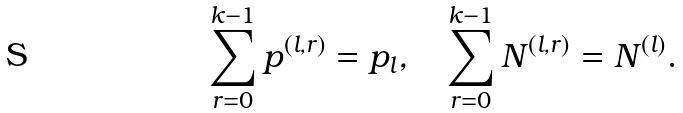Convert formula to latex. <formula><loc_0><loc_0><loc_500><loc_500>\sum _ { r = 0 } ^ { k - 1 } p ^ { ( l , r ) } = p _ { l } , \quad \sum _ { r = 0 } ^ { k - 1 } N ^ { ( l , r ) } = N ^ { ( l ) } .</formula> 